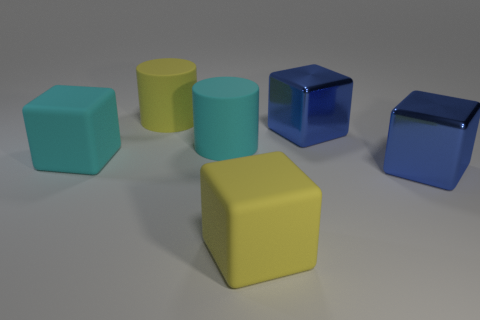Are there fewer large rubber things than cyan rubber things?
Offer a very short reply. No. Do the blue thing that is behind the large cyan matte cylinder and the yellow object that is in front of the big yellow cylinder have the same size?
Give a very brief answer. Yes. What number of green objects are either blocks or cylinders?
Provide a succinct answer. 0. Are there more big cyan rubber blocks than big cyan matte things?
Give a very brief answer. No. What number of objects are either gray balls or big cubes that are right of the cyan matte cylinder?
Keep it short and to the point. 3. Is the number of large cylinders right of the large yellow rubber cube less than the number of big matte cubes left of the cyan matte cube?
Your answer should be compact. No. Is there any other thing that has the same material as the big yellow cylinder?
Your answer should be compact. Yes. What shape is the yellow object that is the same material as the big yellow cylinder?
Provide a short and direct response. Cube. What is the color of the rubber block that is left of the rubber cube that is in front of the big cyan cube?
Offer a very short reply. Cyan. There is a yellow object that is in front of the large yellow object behind the big blue block behind the large cyan matte cube; what is it made of?
Your response must be concise. Rubber. 